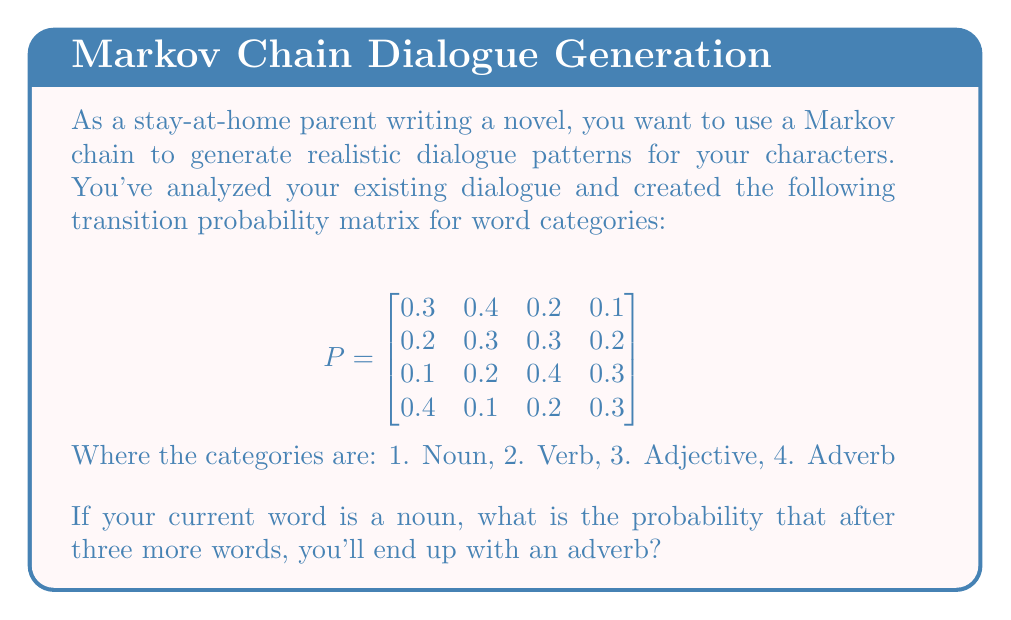Give your solution to this math problem. To solve this problem, we need to use the properties of Markov chains and matrix multiplication. We're looking for the probability of starting at state 1 (noun) and ending at state 4 (adverb) after three steps.

Step 1: We need to calculate $P^3$, which represents the transition probabilities after three steps.

$P^3 = P \times P \times P$

Step 2: Let's calculate $P^2$ first:

$$P^2 = \begin{bmatrix}
0.25 & 0.29 & 0.29 & 0.17 \\
0.22 & 0.27 & 0.30 & 0.21 \\
0.22 & 0.22 & 0.31 & 0.25 \\
0.28 & 0.31 & 0.26 & 0.15
\end{bmatrix}$$

Step 3: Now let's multiply $P^2$ by $P$ to get $P^3$:

$$P^3 = \begin{bmatrix}
0.242 & 0.274 & 0.292 & 0.192 \\
0.233 & 0.262 & 0.297 & 0.208 \\
0.233 & 0.249 & 0.301 & 0.217 \\
0.253 & 0.287 & 0.281 & 0.179
\end{bmatrix}$$

Step 4: The probability we're looking for is the element in the first row (starting state: noun) and fourth column (ending state: adverb) of $P^3$.

Therefore, the probability of starting with a noun and ending with an adverb after three words is 0.192 or 19.2%.
Answer: 0.192 